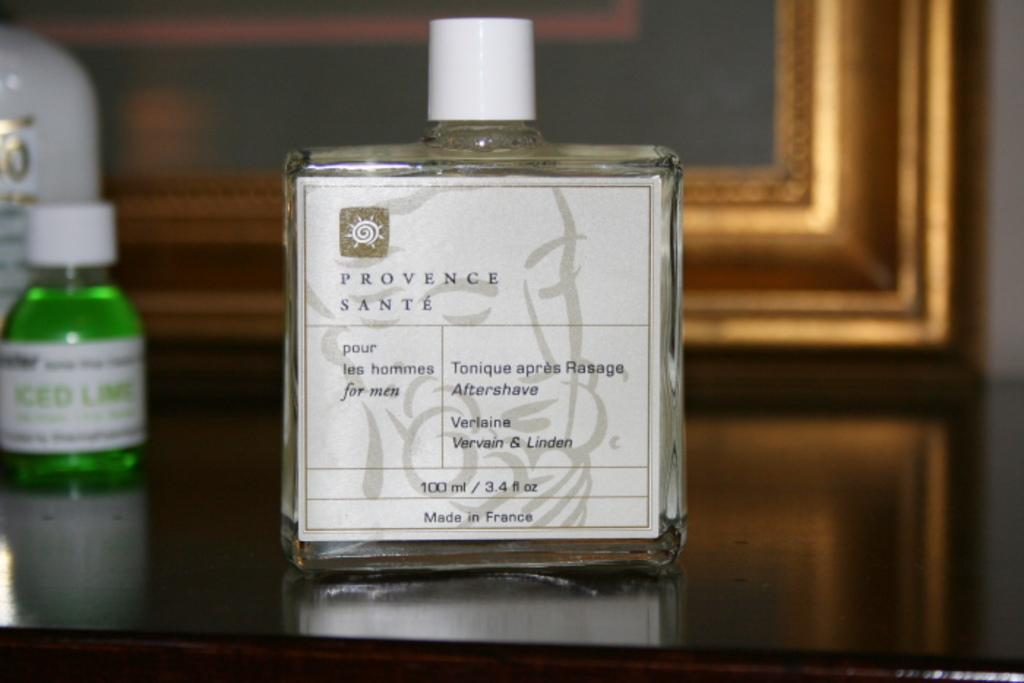<image>
Share a concise interpretation of the image provided. A bottle of Provence Sante for men sits on a dresser. 